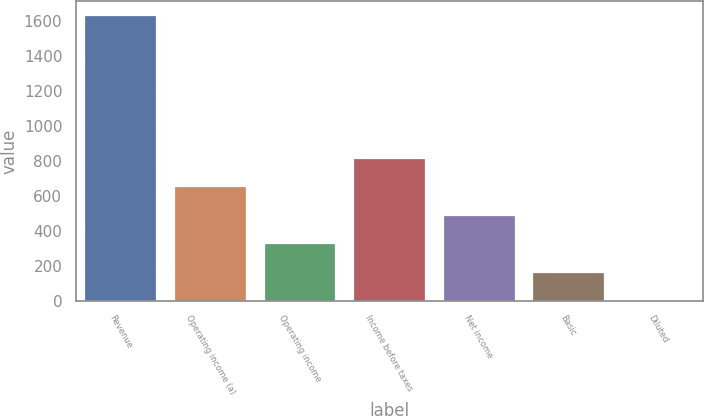<chart> <loc_0><loc_0><loc_500><loc_500><bar_chart><fcel>Revenue<fcel>Operating income (a)<fcel>Operating income<fcel>Income before taxes<fcel>Net income<fcel>Basic<fcel>Diluted<nl><fcel>1631.5<fcel>653.33<fcel>327.27<fcel>816.36<fcel>490.3<fcel>164.24<fcel>1.21<nl></chart> 